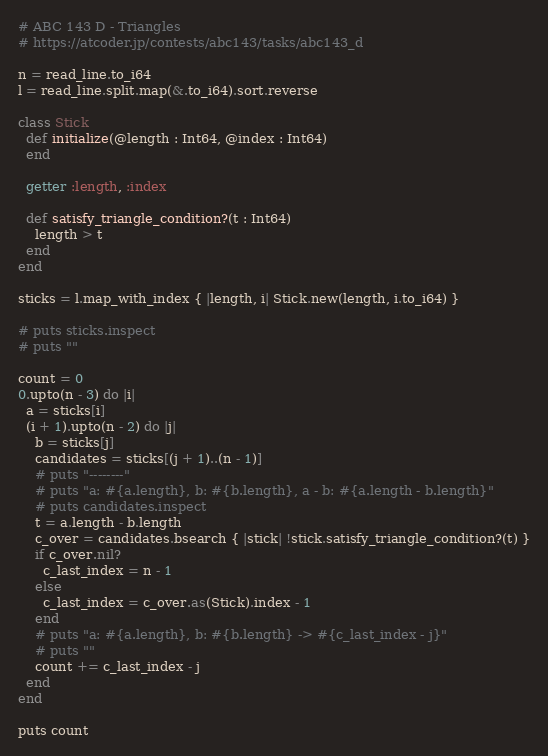<code> <loc_0><loc_0><loc_500><loc_500><_Crystal_># ABC 143 D - Triangles
# https://atcoder.jp/contests/abc143/tasks/abc143_d

n = read_line.to_i64
l = read_line.split.map(&.to_i64).sort.reverse

class Stick
  def initialize(@length : Int64, @index : Int64)
  end

  getter :length, :index

  def satisfy_triangle_condition?(t : Int64)
    length > t
  end
end

sticks = l.map_with_index { |length, i| Stick.new(length, i.to_i64) }

# puts sticks.inspect
# puts ""

count = 0
0.upto(n - 3) do |i|
  a = sticks[i]
  (i + 1).upto(n - 2) do |j|
    b = sticks[j]
    candidates = sticks[(j + 1)..(n - 1)]
    # puts "--------"
    # puts "a: #{a.length}, b: #{b.length}, a - b: #{a.length - b.length}"
    # puts candidates.inspect
    t = a.length - b.length
    c_over = candidates.bsearch { |stick| !stick.satisfy_triangle_condition?(t) }
    if c_over.nil?
      c_last_index = n - 1
    else
      c_last_index = c_over.as(Stick).index - 1
    end
    # puts "a: #{a.length}, b: #{b.length} -> #{c_last_index - j}"
    # puts ""
    count += c_last_index - j
  end
end

puts count
</code> 